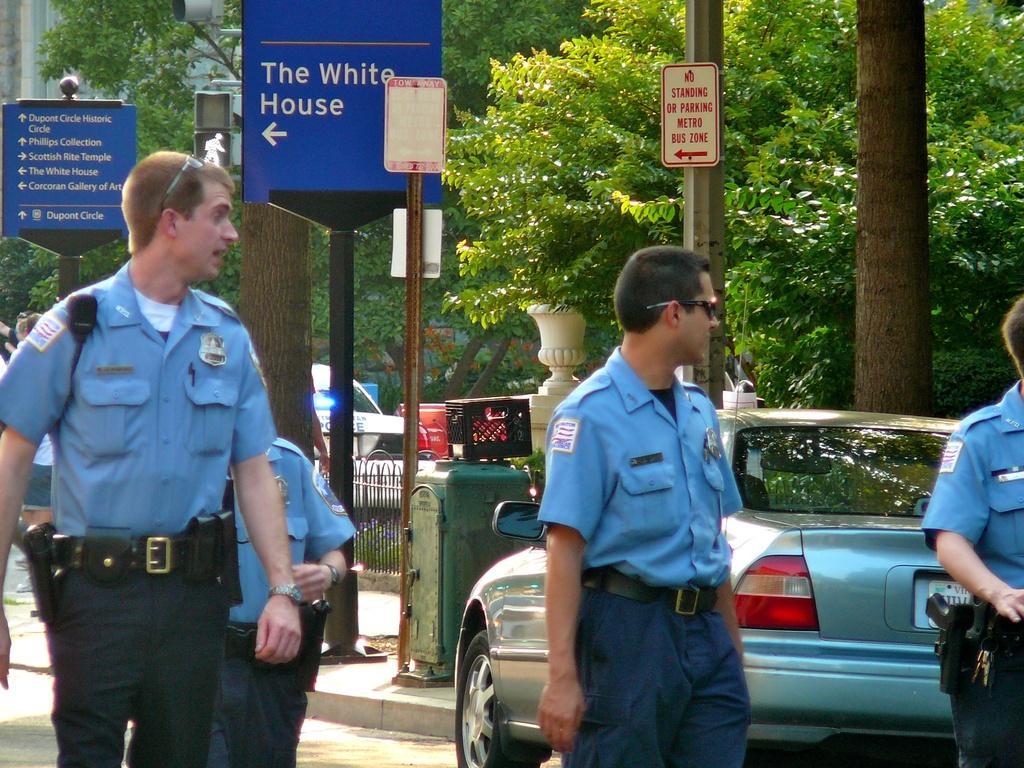Can you describe this image briefly? In the foreground of the picture there are people walking down the road. On the right there are poles, trees, car and other objects. In the center of the picture there are boards, car, railing, trees and sculptures. On the left there are boards, signal lights, trees and building. 